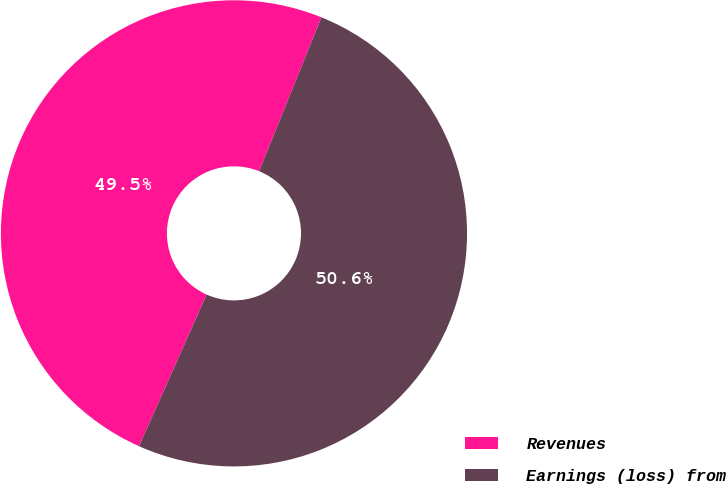<chart> <loc_0><loc_0><loc_500><loc_500><pie_chart><fcel>Revenues<fcel>Earnings (loss) from<nl><fcel>49.45%<fcel>50.55%<nl></chart> 